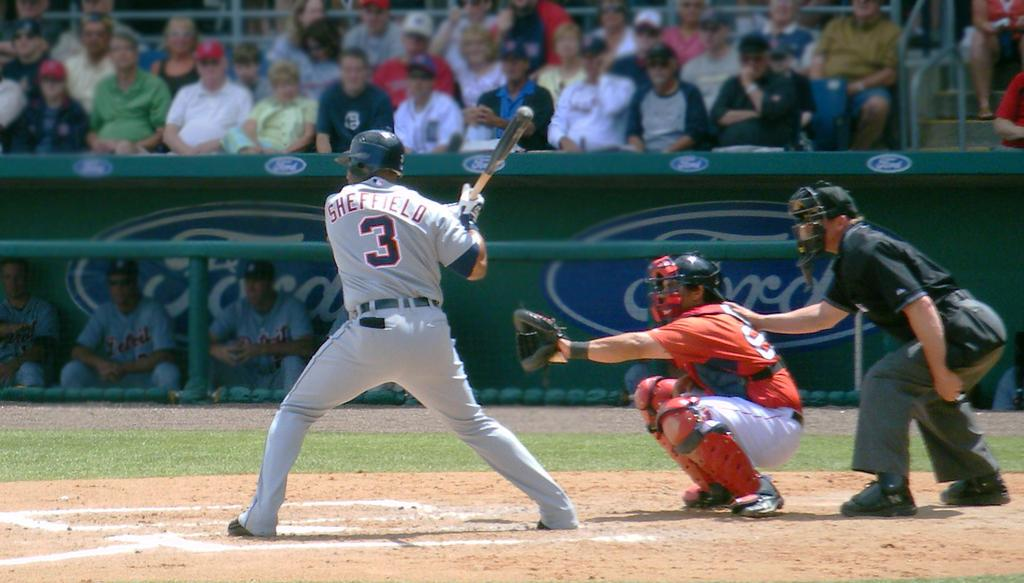<image>
Give a short and clear explanation of the subsequent image. A batter wears a uniform with number 3 and Sheffield on the back. 